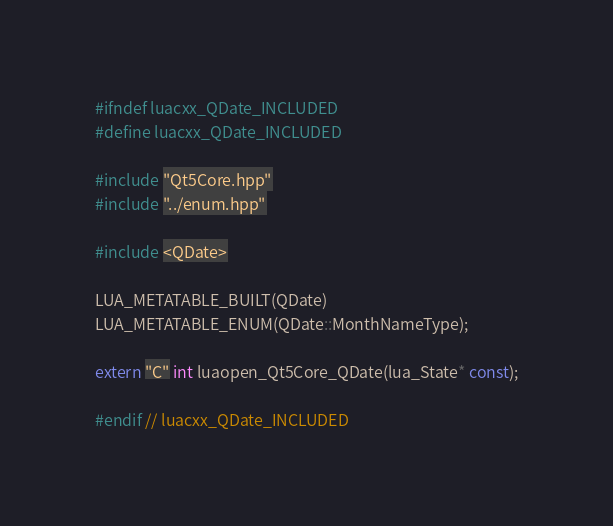<code> <loc_0><loc_0><loc_500><loc_500><_C++_>#ifndef luacxx_QDate_INCLUDED
#define luacxx_QDate_INCLUDED

#include "Qt5Core.hpp"
#include "../enum.hpp"

#include <QDate>

LUA_METATABLE_BUILT(QDate)
LUA_METATABLE_ENUM(QDate::MonthNameType);

extern "C" int luaopen_Qt5Core_QDate(lua_State* const);

#endif // luacxx_QDate_INCLUDED
</code> 